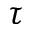Convert formula to latex. <formula><loc_0><loc_0><loc_500><loc_500>\tau</formula> 